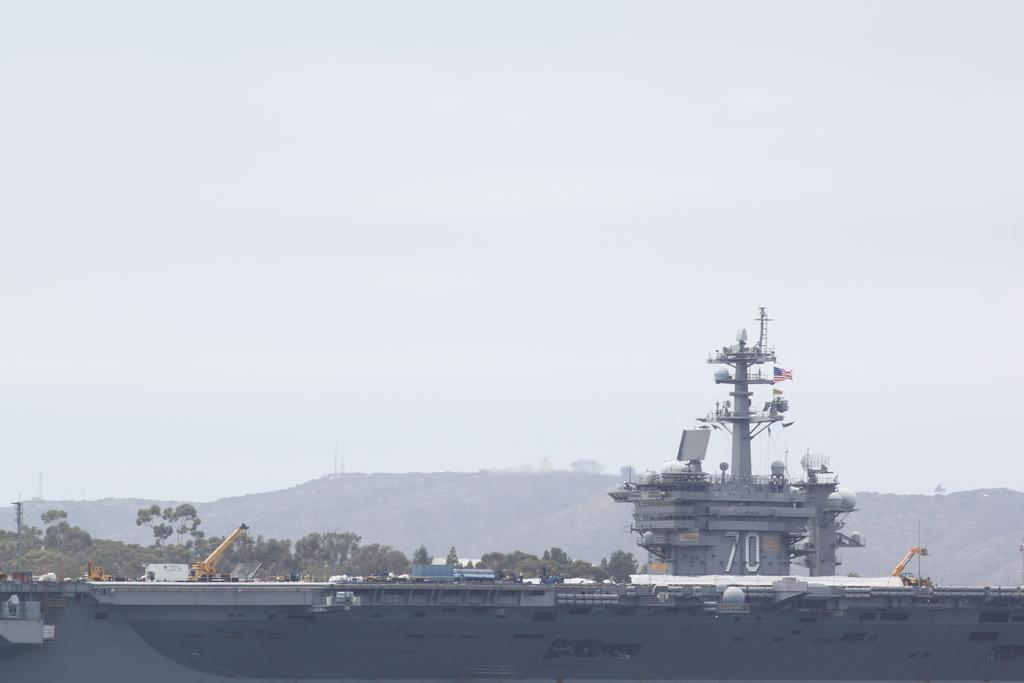What is located at the bottom of the image? There is a ship at the bottom of the image. What structures can be seen in the image? There are cranes in the image. What type of natural scenery is visible in the background of the image? There are trees and hills in the background of the image. What part of the natural environment is visible in the image? The sky is visible in the background of the image. What type of guitar can be seen being played by the trees in the image? There is no guitar present in the image; it features a ship, cranes, trees, hills, and the sky. Is there any blood visible in the image? No, there is no blood visible in the image. 